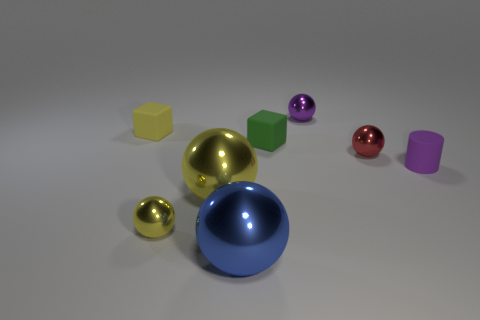Subtract all blue balls. How many balls are left? 4 Subtract all blue shiny balls. How many balls are left? 4 Subtract all green balls. Subtract all cyan blocks. How many balls are left? 5 Add 1 matte things. How many objects exist? 9 Subtract all balls. How many objects are left? 3 Subtract all big objects. Subtract all tiny metal spheres. How many objects are left? 3 Add 2 yellow blocks. How many yellow blocks are left? 3 Add 1 small green blocks. How many small green blocks exist? 2 Subtract 1 yellow spheres. How many objects are left? 7 